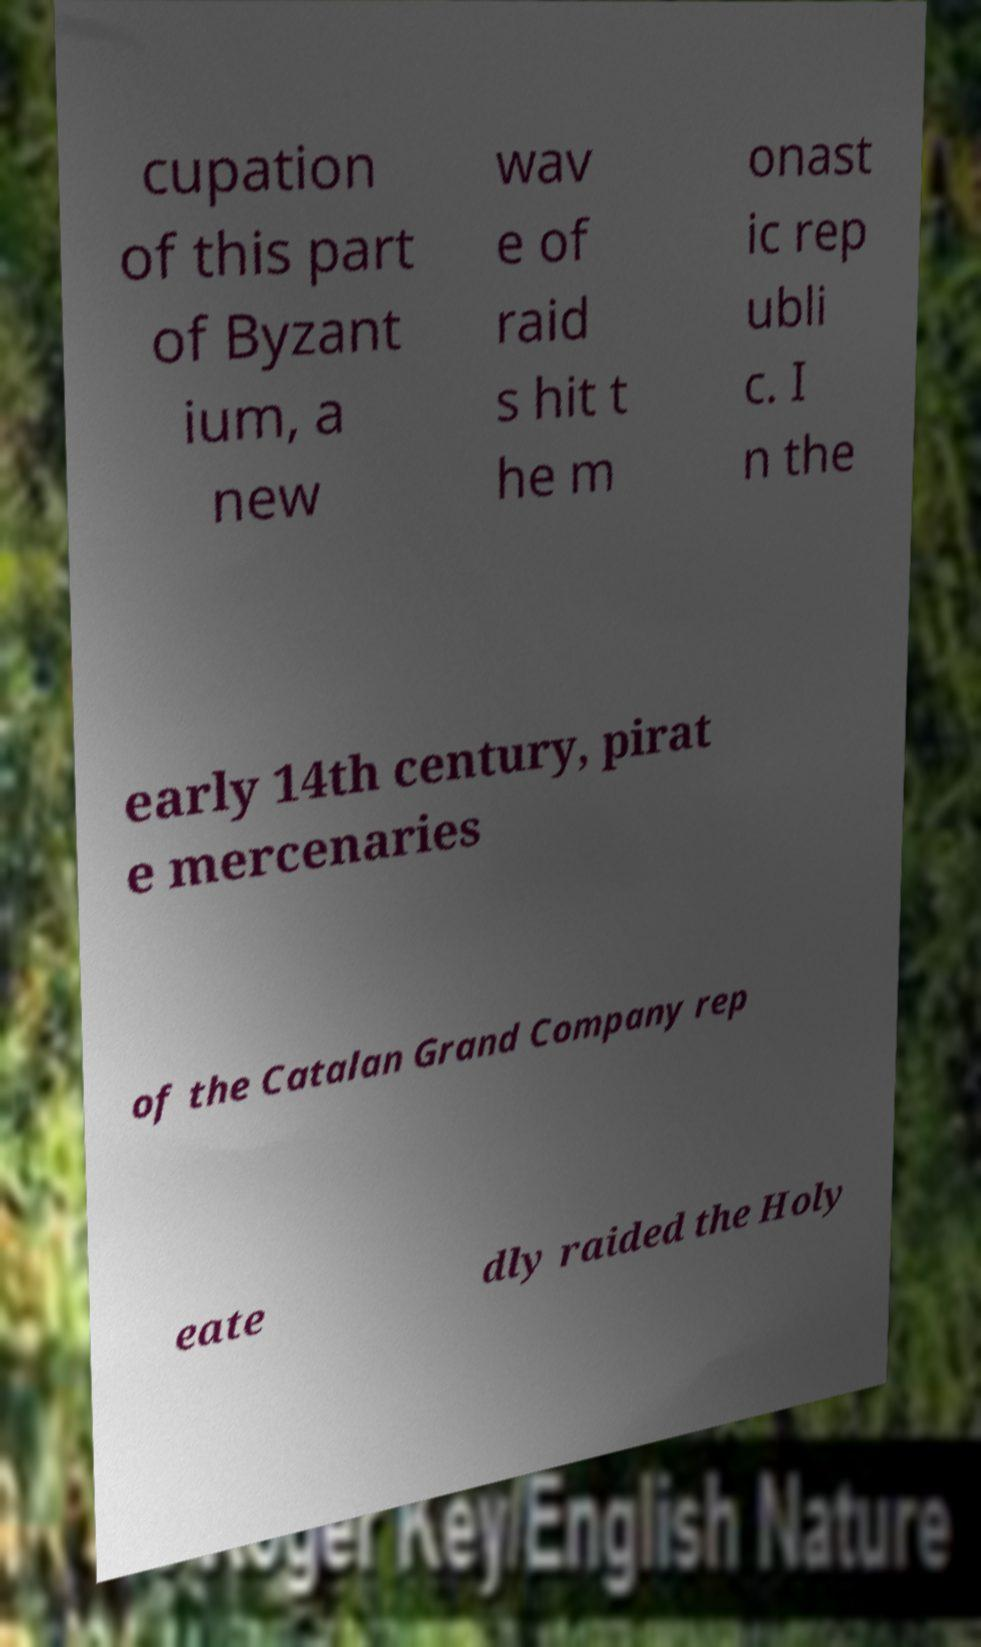I need the written content from this picture converted into text. Can you do that? cupation of this part of Byzant ium, a new wav e of raid s hit t he m onast ic rep ubli c. I n the early 14th century, pirat e mercenaries of the Catalan Grand Company rep eate dly raided the Holy 